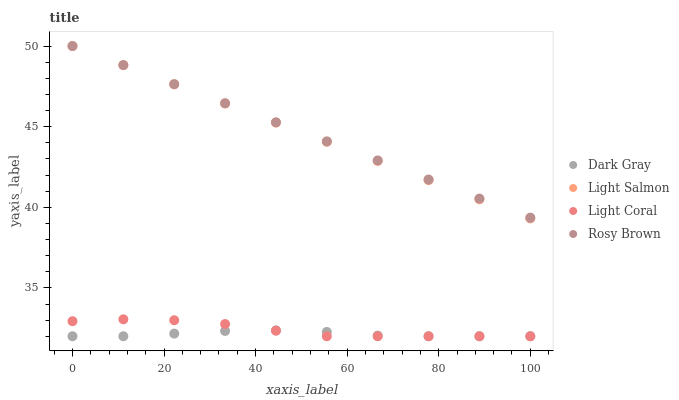Does Dark Gray have the minimum area under the curve?
Answer yes or no. Yes. Does Rosy Brown have the maximum area under the curve?
Answer yes or no. Yes. Does Light Coral have the minimum area under the curve?
Answer yes or no. No. Does Light Coral have the maximum area under the curve?
Answer yes or no. No. Is Rosy Brown the smoothest?
Answer yes or no. Yes. Is Light Coral the roughest?
Answer yes or no. Yes. Is Light Salmon the smoothest?
Answer yes or no. No. Is Light Salmon the roughest?
Answer yes or no. No. Does Dark Gray have the lowest value?
Answer yes or no. Yes. Does Light Salmon have the lowest value?
Answer yes or no. No. Does Rosy Brown have the highest value?
Answer yes or no. Yes. Does Light Coral have the highest value?
Answer yes or no. No. Is Dark Gray less than Rosy Brown?
Answer yes or no. Yes. Is Light Salmon greater than Light Coral?
Answer yes or no. Yes. Does Light Coral intersect Dark Gray?
Answer yes or no. Yes. Is Light Coral less than Dark Gray?
Answer yes or no. No. Is Light Coral greater than Dark Gray?
Answer yes or no. No. Does Dark Gray intersect Rosy Brown?
Answer yes or no. No. 